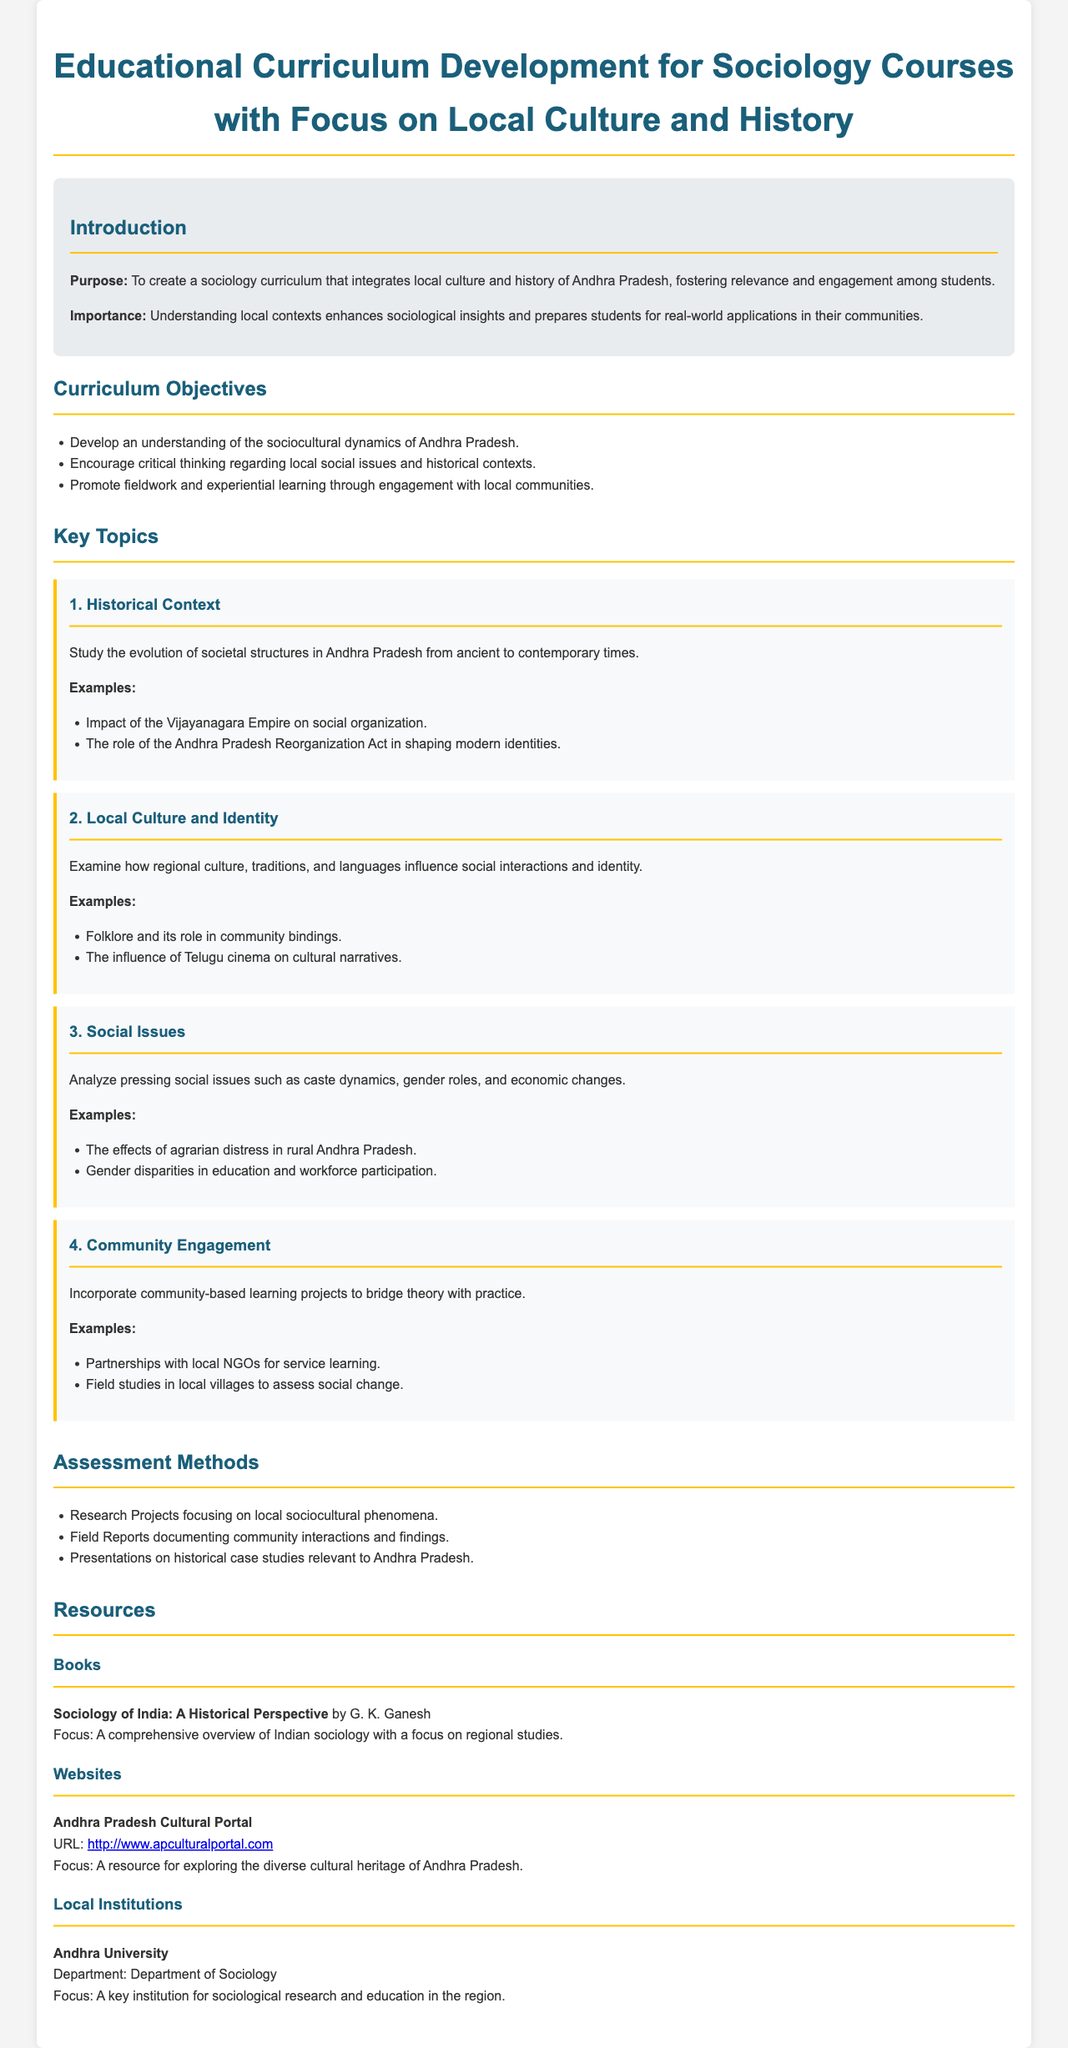What is the purpose of the curriculum? The purpose is to create a sociology curriculum that integrates local culture and history of Andhra Pradesh.
Answer: To create a sociology curriculum that integrates local culture and history of Andhra Pradesh What is one objective of the curriculum? One objective includes developing an understanding of the sociocultural dynamics of Andhra Pradesh.
Answer: Develop an understanding of the sociocultural dynamics of Andhra Pradesh What is a key topic discussed in the curriculum? A key topic is "Local Culture and Identity" which examines how regional culture influences social interactions.
Answer: Local Culture and Identity How many key topics are listed in the document? The document lists four key topics in the curriculum.
Answer: Four What is one assessment method mentioned? One assessment method mentioned is Research Projects focusing on local sociocultural phenomena.
Answer: Research Projects What book is recommended in the resources? The recommended book is "Sociology of India: A Historical Perspective" by G. K. Ganesh.
Answer: Sociology of India: A Historical Perspective What type of community engagement is encouraged? The document encourages partnerships with local NGOs for service learning.
Answer: Partnerships with local NGOs Which institution is highlighted in the resources section? The highlighted institution is Andhra University.
Answer: Andhra University 